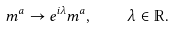Convert formula to latex. <formula><loc_0><loc_0><loc_500><loc_500>m ^ { a } \rightarrow e ^ { i \lambda } m ^ { a } , \quad \lambda \in \mathbb { R } .</formula> 